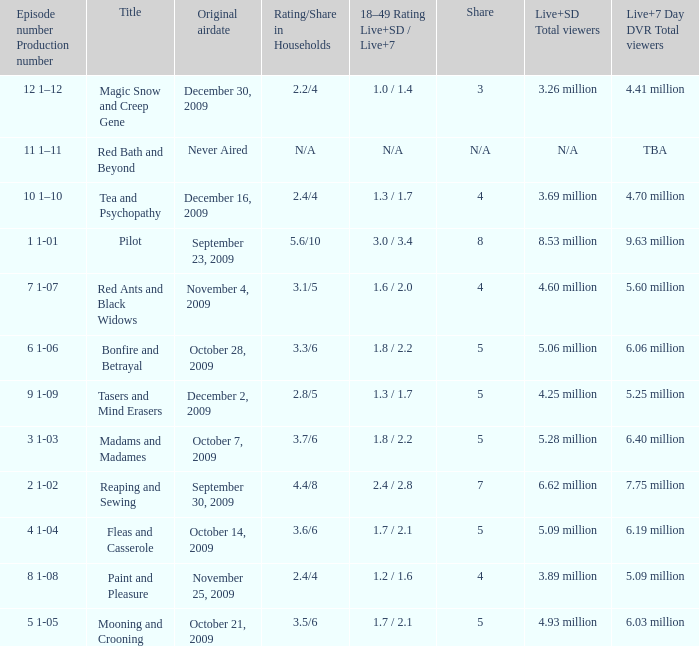When did the fourth episode of the season (4 1-04) first air? October 14, 2009. 